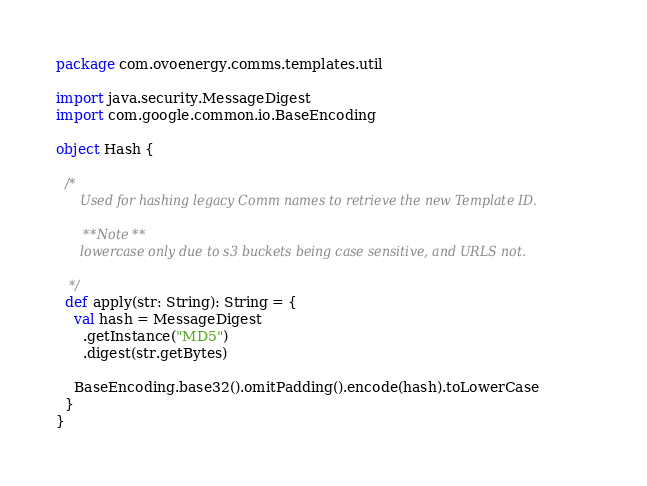<code> <loc_0><loc_0><loc_500><loc_500><_Scala_>package com.ovoenergy.comms.templates.util

import java.security.MessageDigest
import com.google.common.io.BaseEncoding

object Hash {

  /*
      Used for hashing legacy Comm names to retrieve the new Template ID.

      **Note**
      lowercase only due to s3 buckets being case sensitive, and URLS not.

   */
  def apply(str: String): String = {
    val hash = MessageDigest
      .getInstance("MD5")
      .digest(str.getBytes)

    BaseEncoding.base32().omitPadding().encode(hash).toLowerCase
  }
}
</code> 